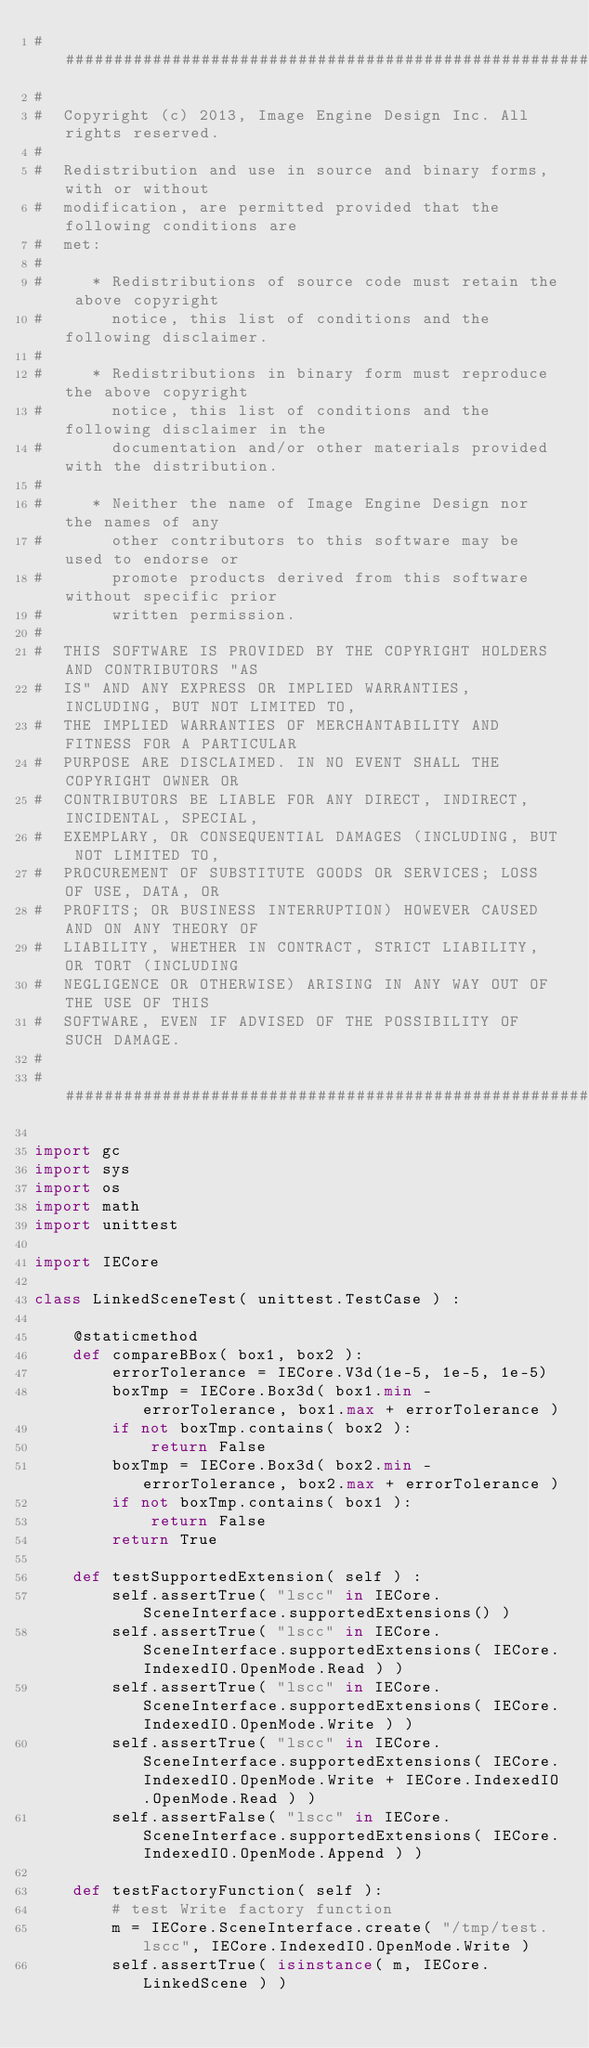Convert code to text. <code><loc_0><loc_0><loc_500><loc_500><_Python_>##########################################################################
#
#  Copyright (c) 2013, Image Engine Design Inc. All rights reserved.
#
#  Redistribution and use in source and binary forms, with or without
#  modification, are permitted provided that the following conditions are
#  met:
#
#     * Redistributions of source code must retain the above copyright
#       notice, this list of conditions and the following disclaimer.
#
#     * Redistributions in binary form must reproduce the above copyright
#       notice, this list of conditions and the following disclaimer in the
#       documentation and/or other materials provided with the distribution.
#
#     * Neither the name of Image Engine Design nor the names of any
#       other contributors to this software may be used to endorse or
#       promote products derived from this software without specific prior
#       written permission.
#
#  THIS SOFTWARE IS PROVIDED BY THE COPYRIGHT HOLDERS AND CONTRIBUTORS "AS
#  IS" AND ANY EXPRESS OR IMPLIED WARRANTIES, INCLUDING, BUT NOT LIMITED TO,
#  THE IMPLIED WARRANTIES OF MERCHANTABILITY AND FITNESS FOR A PARTICULAR
#  PURPOSE ARE DISCLAIMED. IN NO EVENT SHALL THE COPYRIGHT OWNER OR
#  CONTRIBUTORS BE LIABLE FOR ANY DIRECT, INDIRECT, INCIDENTAL, SPECIAL,
#  EXEMPLARY, OR CONSEQUENTIAL DAMAGES (INCLUDING, BUT NOT LIMITED TO,
#  PROCUREMENT OF SUBSTITUTE GOODS OR SERVICES; LOSS OF USE, DATA, OR
#  PROFITS; OR BUSINESS INTERRUPTION) HOWEVER CAUSED AND ON ANY THEORY OF
#  LIABILITY, WHETHER IN CONTRACT, STRICT LIABILITY, OR TORT (INCLUDING
#  NEGLIGENCE OR OTHERWISE) ARISING IN ANY WAY OUT OF THE USE OF THIS
#  SOFTWARE, EVEN IF ADVISED OF THE POSSIBILITY OF SUCH DAMAGE.
#
##########################################################################

import gc
import sys
import os
import math
import unittest

import IECore

class LinkedSceneTest( unittest.TestCase ) :
	
	@staticmethod
	def compareBBox( box1, box2 ):
		errorTolerance = IECore.V3d(1e-5, 1e-5, 1e-5)
		boxTmp = IECore.Box3d( box1.min - errorTolerance, box1.max + errorTolerance )
		if not boxTmp.contains( box2 ):
			return False
		boxTmp = IECore.Box3d( box2.min - errorTolerance, box2.max + errorTolerance )
		if not boxTmp.contains( box1 ):
			return False
		return True
	
	def testSupportedExtension( self ) :
		self.assertTrue( "lscc" in IECore.SceneInterface.supportedExtensions() )
		self.assertTrue( "lscc" in IECore.SceneInterface.supportedExtensions( IECore.IndexedIO.OpenMode.Read ) )
		self.assertTrue( "lscc" in IECore.SceneInterface.supportedExtensions( IECore.IndexedIO.OpenMode.Write ) )
		self.assertTrue( "lscc" in IECore.SceneInterface.supportedExtensions( IECore.IndexedIO.OpenMode.Write + IECore.IndexedIO.OpenMode.Read ) )
		self.assertFalse( "lscc" in IECore.SceneInterface.supportedExtensions( IECore.IndexedIO.OpenMode.Append ) )

	def testFactoryFunction( self ):
		# test Write factory function 
		m = IECore.SceneInterface.create( "/tmp/test.lscc", IECore.IndexedIO.OpenMode.Write )
		self.assertTrue( isinstance( m, IECore.LinkedScene ) )</code> 